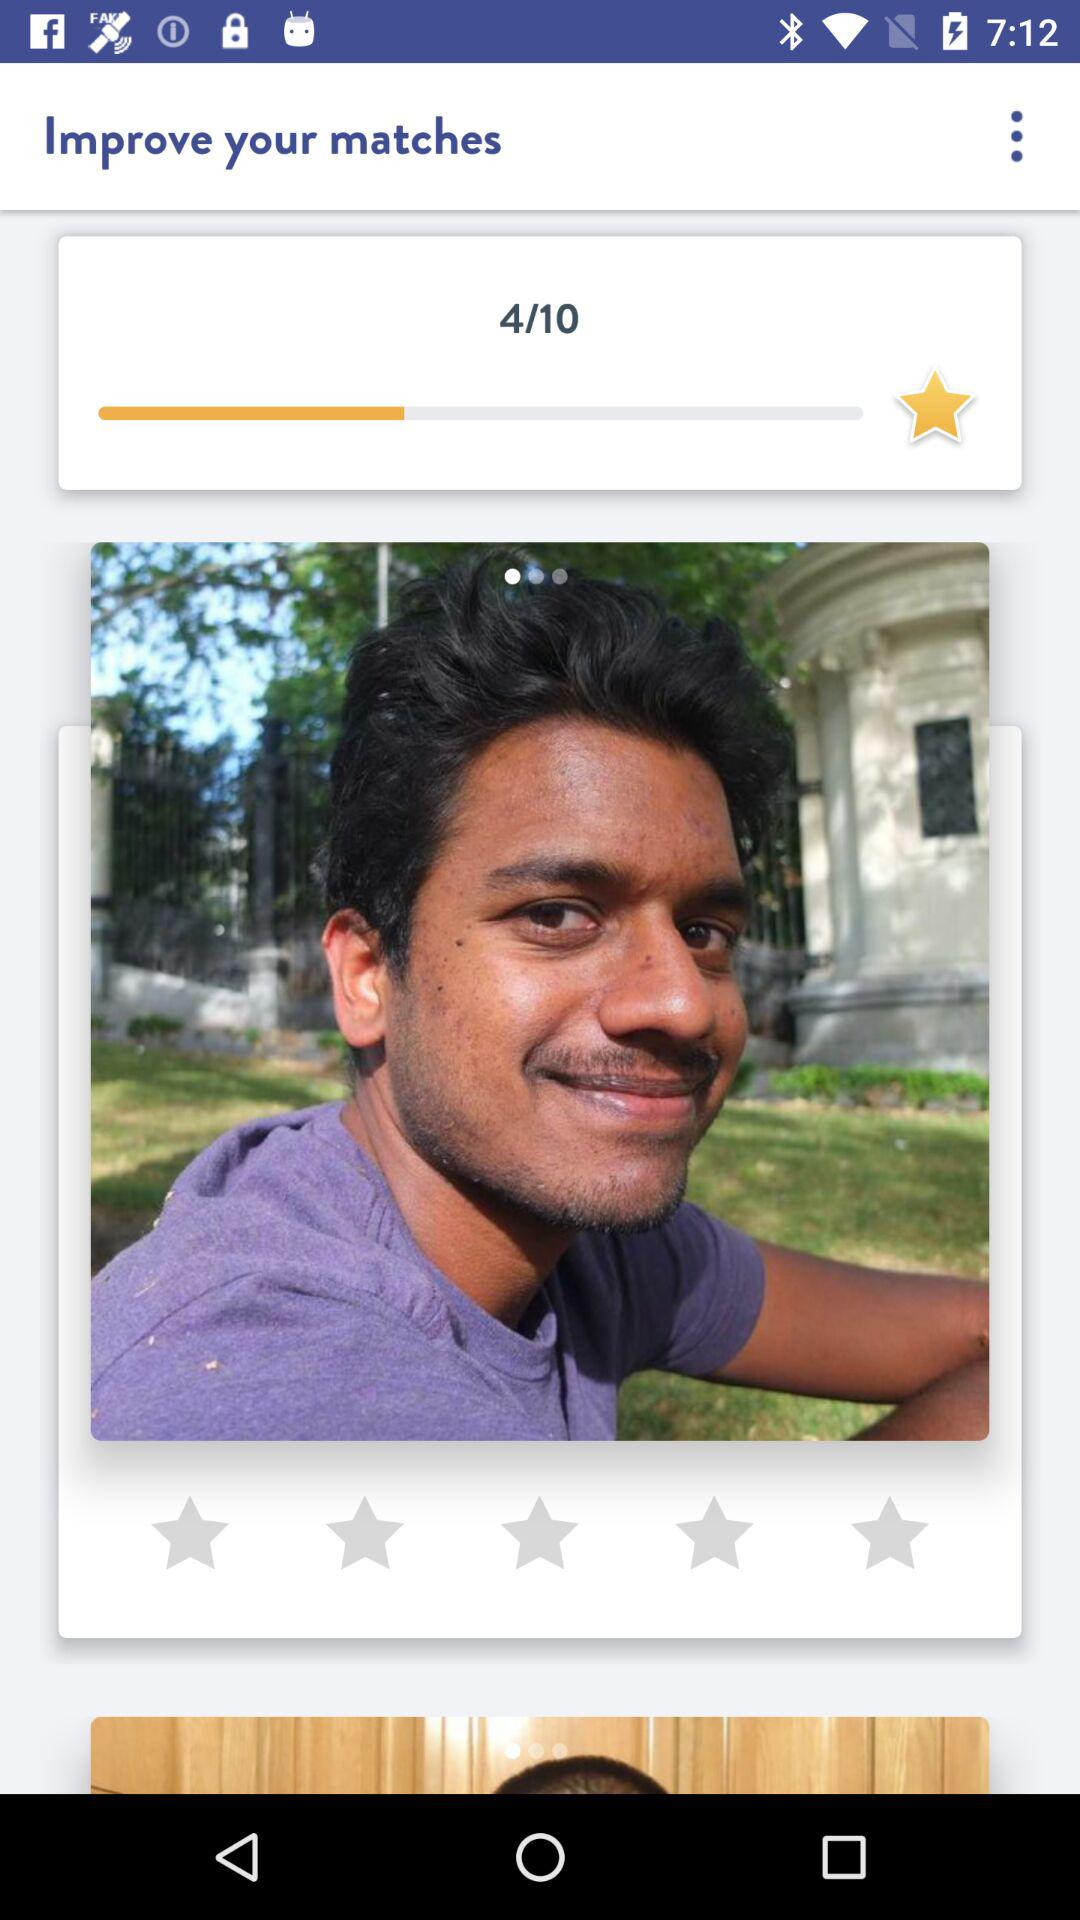What's the total number of stars to be achieved to find the perfect match? The total number of stars is 10. 